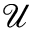<formula> <loc_0><loc_0><loc_500><loc_500>\mathcal { U }</formula> 